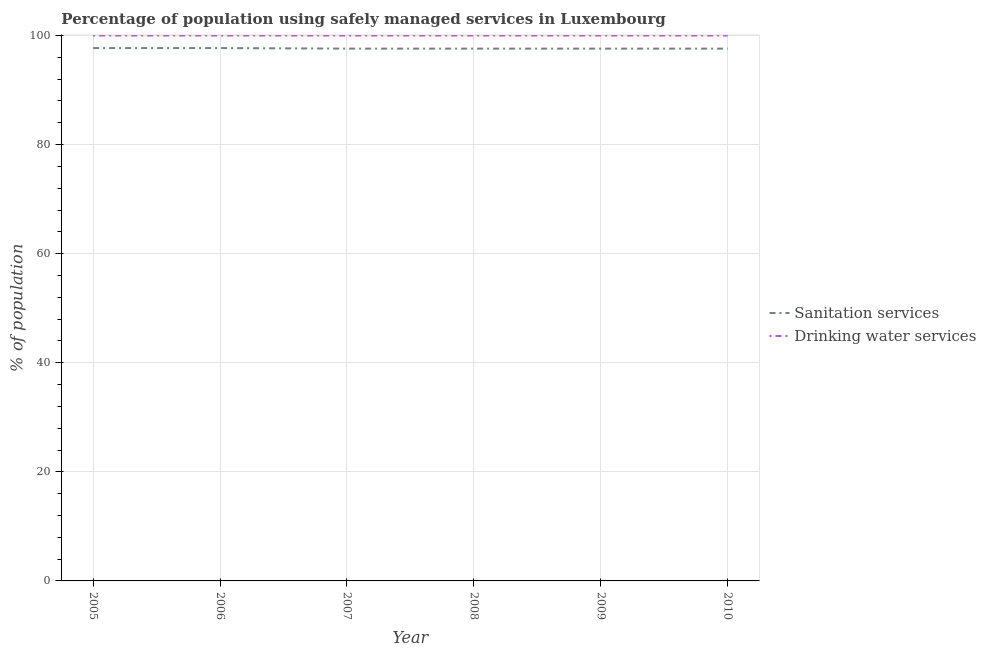How many different coloured lines are there?
Keep it short and to the point. 2. Is the number of lines equal to the number of legend labels?
Your answer should be compact. Yes. What is the percentage of population who used sanitation services in 2006?
Keep it short and to the point. 97.7. Across all years, what is the maximum percentage of population who used drinking water services?
Your answer should be very brief. 100. Across all years, what is the minimum percentage of population who used sanitation services?
Give a very brief answer. 97.6. In which year was the percentage of population who used sanitation services maximum?
Your response must be concise. 2005. In which year was the percentage of population who used drinking water services minimum?
Your response must be concise. 2005. What is the total percentage of population who used drinking water services in the graph?
Ensure brevity in your answer.  600. What is the difference between the percentage of population who used sanitation services in 2006 and the percentage of population who used drinking water services in 2009?
Offer a terse response. -2.3. What is the average percentage of population who used sanitation services per year?
Your answer should be compact. 97.63. In the year 2008, what is the difference between the percentage of population who used sanitation services and percentage of population who used drinking water services?
Make the answer very short. -2.4. In how many years, is the percentage of population who used drinking water services greater than 52 %?
Provide a succinct answer. 6. What is the ratio of the percentage of population who used sanitation services in 2006 to that in 2008?
Give a very brief answer. 1. Is the percentage of population who used sanitation services in 2009 less than that in 2010?
Your response must be concise. No. What is the difference between the highest and the lowest percentage of population who used sanitation services?
Provide a succinct answer. 0.1. Is the sum of the percentage of population who used drinking water services in 2005 and 2007 greater than the maximum percentage of population who used sanitation services across all years?
Ensure brevity in your answer.  Yes. Is the percentage of population who used sanitation services strictly less than the percentage of population who used drinking water services over the years?
Keep it short and to the point. Yes. What is the difference between two consecutive major ticks on the Y-axis?
Offer a very short reply. 20. Does the graph contain grids?
Give a very brief answer. Yes. What is the title of the graph?
Your answer should be very brief. Percentage of population using safely managed services in Luxembourg. Does "Urban Population" appear as one of the legend labels in the graph?
Offer a terse response. No. What is the label or title of the X-axis?
Your answer should be very brief. Year. What is the label or title of the Y-axis?
Keep it short and to the point. % of population. What is the % of population of Sanitation services in 2005?
Ensure brevity in your answer.  97.7. What is the % of population of Drinking water services in 2005?
Your response must be concise. 100. What is the % of population of Sanitation services in 2006?
Keep it short and to the point. 97.7. What is the % of population in Sanitation services in 2007?
Make the answer very short. 97.6. What is the % of population in Drinking water services in 2007?
Your answer should be compact. 100. What is the % of population in Sanitation services in 2008?
Keep it short and to the point. 97.6. What is the % of population in Sanitation services in 2009?
Ensure brevity in your answer.  97.6. What is the % of population of Drinking water services in 2009?
Offer a very short reply. 100. What is the % of population of Sanitation services in 2010?
Your answer should be compact. 97.6. Across all years, what is the maximum % of population in Sanitation services?
Offer a terse response. 97.7. Across all years, what is the maximum % of population in Drinking water services?
Give a very brief answer. 100. Across all years, what is the minimum % of population of Sanitation services?
Make the answer very short. 97.6. Across all years, what is the minimum % of population in Drinking water services?
Your answer should be very brief. 100. What is the total % of population of Sanitation services in the graph?
Provide a short and direct response. 585.8. What is the total % of population of Drinking water services in the graph?
Ensure brevity in your answer.  600. What is the difference between the % of population of Sanitation services in 2005 and that in 2007?
Ensure brevity in your answer.  0.1. What is the difference between the % of population of Drinking water services in 2005 and that in 2007?
Make the answer very short. 0. What is the difference between the % of population of Drinking water services in 2005 and that in 2008?
Your answer should be compact. 0. What is the difference between the % of population of Sanitation services in 2005 and that in 2009?
Your answer should be very brief. 0.1. What is the difference between the % of population of Sanitation services in 2005 and that in 2010?
Offer a very short reply. 0.1. What is the difference between the % of population in Drinking water services in 2005 and that in 2010?
Offer a terse response. 0. What is the difference between the % of population of Sanitation services in 2006 and that in 2007?
Ensure brevity in your answer.  0.1. What is the difference between the % of population in Drinking water services in 2006 and that in 2007?
Provide a short and direct response. 0. What is the difference between the % of population in Sanitation services in 2006 and that in 2008?
Your answer should be compact. 0.1. What is the difference between the % of population in Sanitation services in 2006 and that in 2009?
Make the answer very short. 0.1. What is the difference between the % of population of Drinking water services in 2006 and that in 2010?
Your answer should be very brief. 0. What is the difference between the % of population of Sanitation services in 2007 and that in 2008?
Provide a succinct answer. 0. What is the difference between the % of population of Drinking water services in 2007 and that in 2010?
Offer a very short reply. 0. What is the difference between the % of population of Sanitation services in 2008 and that in 2009?
Provide a succinct answer. 0. What is the difference between the % of population in Drinking water services in 2008 and that in 2009?
Keep it short and to the point. 0. What is the difference between the % of population in Drinking water services in 2008 and that in 2010?
Give a very brief answer. 0. What is the difference between the % of population of Drinking water services in 2009 and that in 2010?
Your response must be concise. 0. What is the difference between the % of population in Sanitation services in 2005 and the % of population in Drinking water services in 2007?
Your answer should be very brief. -2.3. What is the difference between the % of population in Sanitation services in 2005 and the % of population in Drinking water services in 2009?
Your answer should be compact. -2.3. What is the difference between the % of population in Sanitation services in 2005 and the % of population in Drinking water services in 2010?
Keep it short and to the point. -2.3. What is the difference between the % of population in Sanitation services in 2006 and the % of population in Drinking water services in 2007?
Keep it short and to the point. -2.3. What is the difference between the % of population of Sanitation services in 2007 and the % of population of Drinking water services in 2008?
Your answer should be very brief. -2.4. What is the difference between the % of population in Sanitation services in 2007 and the % of population in Drinking water services in 2009?
Your response must be concise. -2.4. What is the difference between the % of population in Sanitation services in 2008 and the % of population in Drinking water services in 2009?
Keep it short and to the point. -2.4. What is the difference between the % of population of Sanitation services in 2009 and the % of population of Drinking water services in 2010?
Offer a terse response. -2.4. What is the average % of population in Sanitation services per year?
Your response must be concise. 97.63. What is the ratio of the % of population of Sanitation services in 2005 to that in 2006?
Your response must be concise. 1. What is the ratio of the % of population in Drinking water services in 2005 to that in 2006?
Ensure brevity in your answer.  1. What is the ratio of the % of population in Sanitation services in 2005 to that in 2007?
Provide a succinct answer. 1. What is the ratio of the % of population of Drinking water services in 2005 to that in 2008?
Your answer should be compact. 1. What is the ratio of the % of population of Drinking water services in 2005 to that in 2010?
Your response must be concise. 1. What is the ratio of the % of population of Sanitation services in 2006 to that in 2007?
Your answer should be compact. 1. What is the ratio of the % of population of Drinking water services in 2006 to that in 2007?
Give a very brief answer. 1. What is the ratio of the % of population in Sanitation services in 2006 to that in 2008?
Make the answer very short. 1. What is the ratio of the % of population of Sanitation services in 2006 to that in 2009?
Offer a very short reply. 1. What is the ratio of the % of population of Drinking water services in 2006 to that in 2010?
Your response must be concise. 1. What is the ratio of the % of population of Sanitation services in 2007 to that in 2008?
Give a very brief answer. 1. What is the ratio of the % of population in Drinking water services in 2007 to that in 2008?
Give a very brief answer. 1. What is the ratio of the % of population in Sanitation services in 2007 to that in 2009?
Provide a short and direct response. 1. What is the ratio of the % of population in Drinking water services in 2007 to that in 2010?
Make the answer very short. 1. What is the ratio of the % of population in Drinking water services in 2008 to that in 2009?
Your response must be concise. 1. What is the ratio of the % of population of Sanitation services in 2008 to that in 2010?
Provide a short and direct response. 1. What is the ratio of the % of population of Drinking water services in 2008 to that in 2010?
Offer a terse response. 1. What is the difference between the highest and the second highest % of population in Sanitation services?
Your answer should be very brief. 0. What is the difference between the highest and the lowest % of population in Sanitation services?
Your answer should be compact. 0.1. 